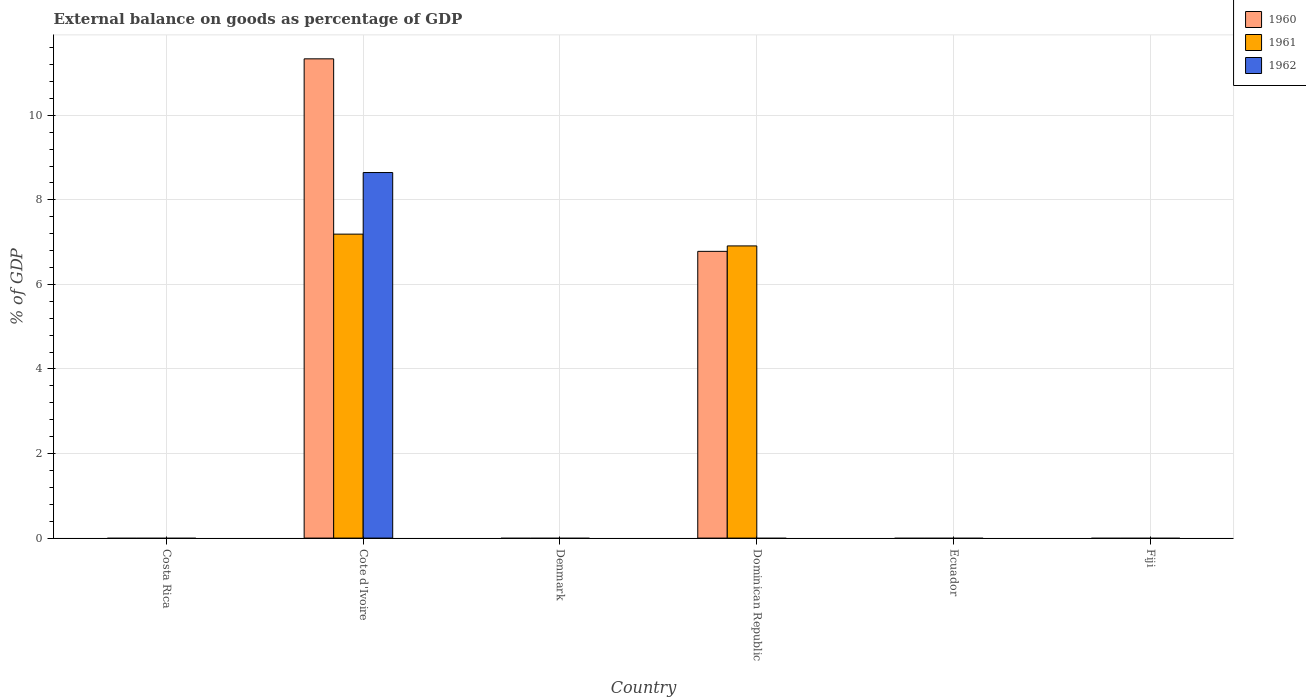In how many cases, is the number of bars for a given country not equal to the number of legend labels?
Offer a very short reply. 5. What is the external balance on goods as percentage of GDP in 1961 in Fiji?
Ensure brevity in your answer.  0. Across all countries, what is the maximum external balance on goods as percentage of GDP in 1962?
Give a very brief answer. 8.65. Across all countries, what is the minimum external balance on goods as percentage of GDP in 1960?
Make the answer very short. 0. In which country was the external balance on goods as percentage of GDP in 1962 maximum?
Make the answer very short. Cote d'Ivoire. What is the total external balance on goods as percentage of GDP in 1961 in the graph?
Offer a very short reply. 14.1. What is the difference between the external balance on goods as percentage of GDP in 1961 in Cote d'Ivoire and that in Dominican Republic?
Give a very brief answer. 0.28. What is the average external balance on goods as percentage of GDP in 1960 per country?
Your answer should be compact. 3.02. What is the difference between the external balance on goods as percentage of GDP of/in 1961 and external balance on goods as percentage of GDP of/in 1962 in Cote d'Ivoire?
Offer a terse response. -1.46. What is the difference between the highest and the lowest external balance on goods as percentage of GDP in 1960?
Your answer should be compact. 11.34. In how many countries, is the external balance on goods as percentage of GDP in 1961 greater than the average external balance on goods as percentage of GDP in 1961 taken over all countries?
Offer a very short reply. 2. Is it the case that in every country, the sum of the external balance on goods as percentage of GDP in 1962 and external balance on goods as percentage of GDP in 1961 is greater than the external balance on goods as percentage of GDP in 1960?
Offer a terse response. No. Are all the bars in the graph horizontal?
Offer a terse response. No. Are the values on the major ticks of Y-axis written in scientific E-notation?
Provide a succinct answer. No. Does the graph contain any zero values?
Your response must be concise. Yes. Where does the legend appear in the graph?
Ensure brevity in your answer.  Top right. How are the legend labels stacked?
Keep it short and to the point. Vertical. What is the title of the graph?
Ensure brevity in your answer.  External balance on goods as percentage of GDP. What is the label or title of the Y-axis?
Offer a very short reply. % of GDP. What is the % of GDP of 1960 in Costa Rica?
Provide a short and direct response. 0. What is the % of GDP in 1961 in Costa Rica?
Your answer should be compact. 0. What is the % of GDP of 1960 in Cote d'Ivoire?
Offer a very short reply. 11.34. What is the % of GDP in 1961 in Cote d'Ivoire?
Offer a terse response. 7.19. What is the % of GDP in 1962 in Cote d'Ivoire?
Offer a very short reply. 8.65. What is the % of GDP in 1962 in Denmark?
Give a very brief answer. 0. What is the % of GDP in 1960 in Dominican Republic?
Your answer should be very brief. 6.78. What is the % of GDP in 1961 in Dominican Republic?
Your answer should be compact. 6.91. What is the % of GDP in 1960 in Ecuador?
Your answer should be very brief. 0. What is the % of GDP of 1961 in Ecuador?
Offer a very short reply. 0. What is the % of GDP in 1960 in Fiji?
Provide a short and direct response. 0. What is the % of GDP in 1961 in Fiji?
Offer a very short reply. 0. What is the % of GDP of 1962 in Fiji?
Offer a terse response. 0. Across all countries, what is the maximum % of GDP of 1960?
Your answer should be very brief. 11.34. Across all countries, what is the maximum % of GDP in 1961?
Your answer should be compact. 7.19. Across all countries, what is the maximum % of GDP of 1962?
Provide a short and direct response. 8.65. Across all countries, what is the minimum % of GDP of 1961?
Give a very brief answer. 0. Across all countries, what is the minimum % of GDP in 1962?
Your answer should be compact. 0. What is the total % of GDP of 1960 in the graph?
Make the answer very short. 18.12. What is the total % of GDP of 1961 in the graph?
Offer a very short reply. 14.1. What is the total % of GDP in 1962 in the graph?
Provide a succinct answer. 8.65. What is the difference between the % of GDP in 1960 in Cote d'Ivoire and that in Dominican Republic?
Keep it short and to the point. 4.55. What is the difference between the % of GDP in 1961 in Cote d'Ivoire and that in Dominican Republic?
Offer a terse response. 0.28. What is the difference between the % of GDP of 1960 in Cote d'Ivoire and the % of GDP of 1961 in Dominican Republic?
Your answer should be very brief. 4.42. What is the average % of GDP of 1960 per country?
Make the answer very short. 3.02. What is the average % of GDP of 1961 per country?
Ensure brevity in your answer.  2.35. What is the average % of GDP of 1962 per country?
Provide a short and direct response. 1.44. What is the difference between the % of GDP in 1960 and % of GDP in 1961 in Cote d'Ivoire?
Your answer should be compact. 4.15. What is the difference between the % of GDP in 1960 and % of GDP in 1962 in Cote d'Ivoire?
Give a very brief answer. 2.69. What is the difference between the % of GDP in 1961 and % of GDP in 1962 in Cote d'Ivoire?
Provide a short and direct response. -1.46. What is the difference between the % of GDP of 1960 and % of GDP of 1961 in Dominican Republic?
Provide a succinct answer. -0.13. What is the ratio of the % of GDP in 1960 in Cote d'Ivoire to that in Dominican Republic?
Provide a short and direct response. 1.67. What is the ratio of the % of GDP of 1961 in Cote d'Ivoire to that in Dominican Republic?
Offer a terse response. 1.04. What is the difference between the highest and the lowest % of GDP in 1960?
Provide a succinct answer. 11.34. What is the difference between the highest and the lowest % of GDP in 1961?
Offer a terse response. 7.19. What is the difference between the highest and the lowest % of GDP of 1962?
Offer a terse response. 8.65. 